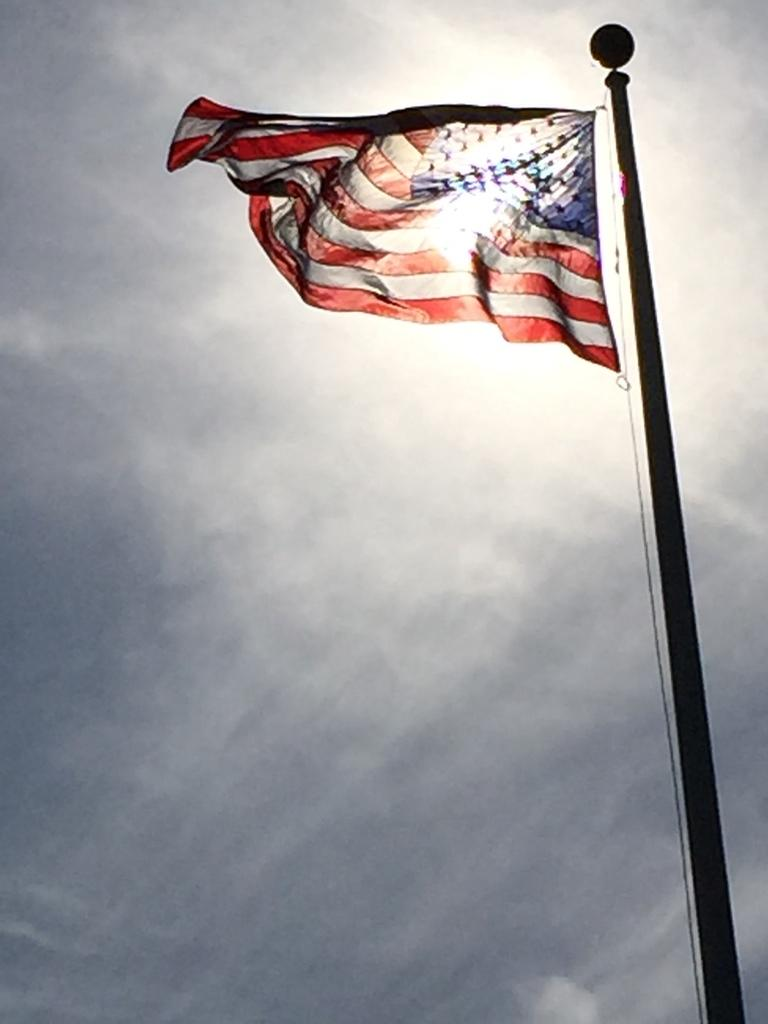What is the main object in the image? There is a flag in the image. How is the flag positioned in the image? The flag is on a pole. What colors are present on the flag? The flag has red, white, and blue colors. What can be seen in the background of the image? There are clouds and the sky visible in the background of the image. What type of jelly is being used to stick the flag to the pole in the image? There is no jelly present in the image; the flag is attached to the pole without any visible adhesive. 